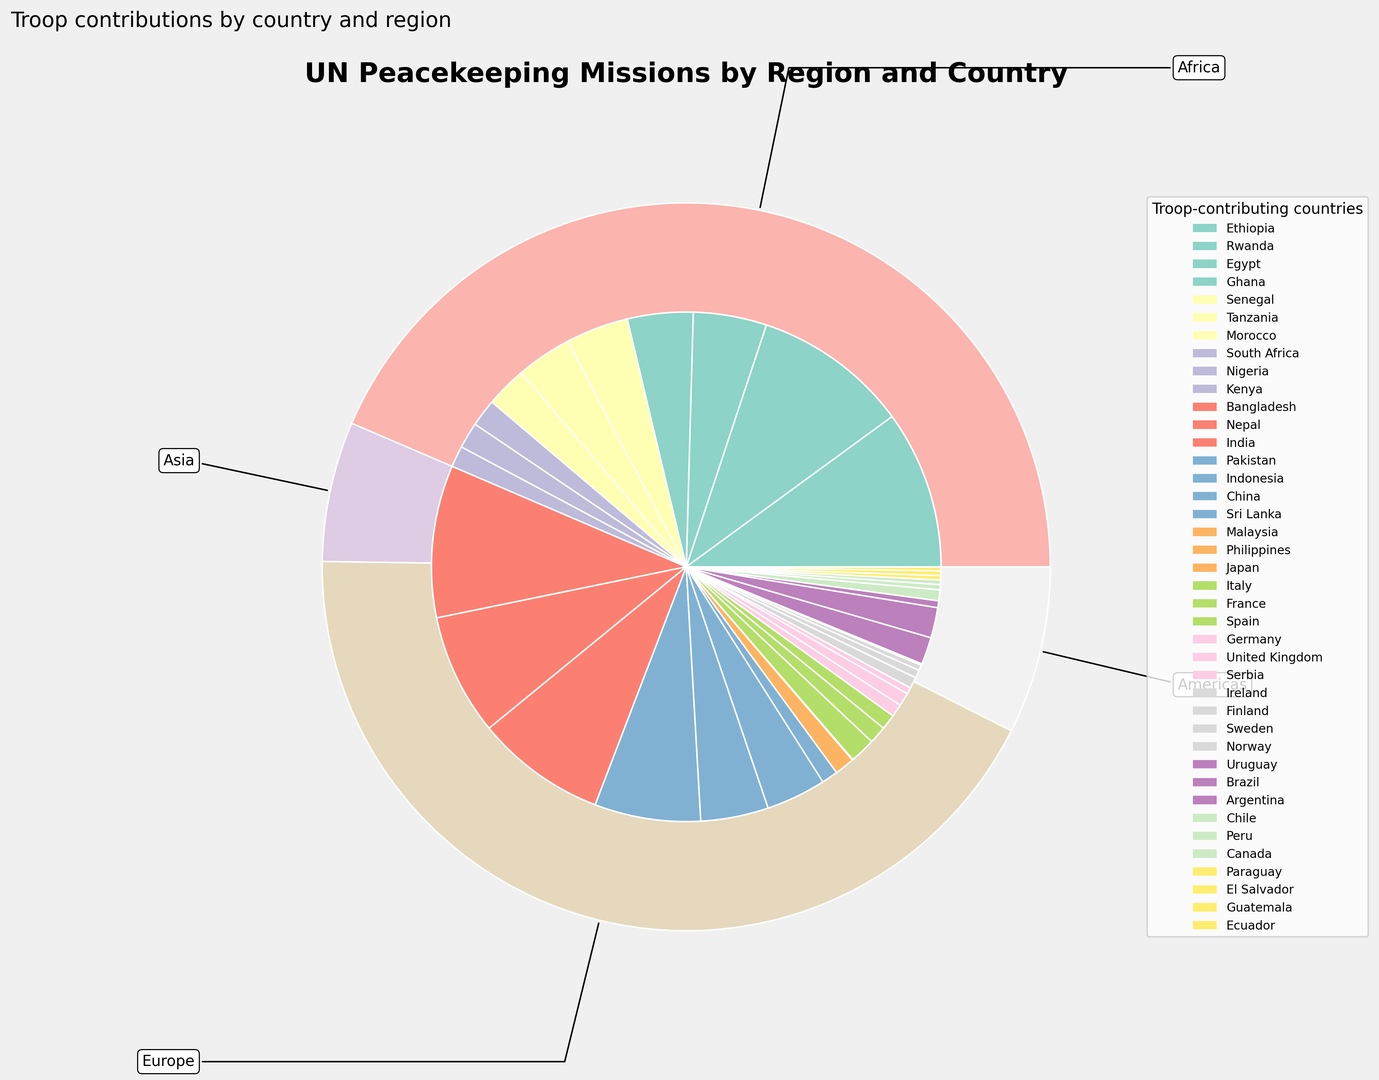Which region contributes the most troops to UN peacekeeping missions? By looking at the outer pie chart, the region with the largest slice represents the region with the highest troop contribution.
Answer: Africa Rank the top three countries in terms of troop contributions. The inner pie chart provides detailed contributions by individual countries. The three largest slices will indicate the top three contributors.
Answer: Ethiopia, Bangladesh, Rwanda Which European country contributes the most troops to UN peacekeeping missions? Within the segment for Europe in the outer pie, the inner pie will show the contributions of individual European countries. The largest slice in this segment represents the highest contributing European country.
Answer: Italy How does the troop contribution of South America compare to that of Africa? Compare the size of the slice for South America (Americas) to that of Africa in the outer pie chart. Africa's slice is significantly larger than South America's.
Answer: Africa contributes more troops What is the total troop contribution from countries contributing less than 1000 troops each? Identify the inner pie slices representing countries with less than 1000 troops, then sum their contributions: Morocco, South Africa, Nigeria, Kenya, Malaysia, Japan, Philippines, Serbia, Ireland, Finland, Sweden, Norway, Argentina, Chile, Peru, Canada, Paraguay, El Salvador, Guatemala, Ecuador. Adding these together gives the total.
Answer: 9613 troops 